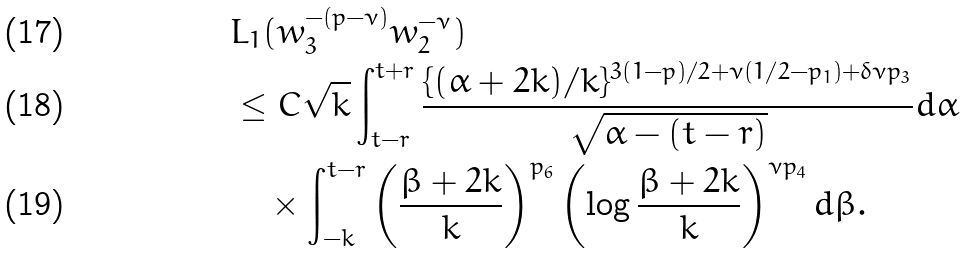<formula> <loc_0><loc_0><loc_500><loc_500>& L _ { 1 } ( w _ { 3 } ^ { - ( p - \nu ) } w _ { 2 } ^ { - \nu } ) \\ & \leq C \sqrt { k } \int _ { t - r } ^ { t + r } \frac { \{ ( \alpha + 2 k ) / k \} ^ { 3 ( 1 - p ) / 2 + \nu ( 1 / 2 - p _ { 1 } ) + \delta \nu p _ { 3 } } } { \sqrt { \alpha - ( t - r ) } } d \alpha \\ & \quad \times \int _ { - k } ^ { t - r } \left ( \frac { \beta + 2 k } { k } \right ) ^ { p _ { 6 } } \left ( \log \frac { \beta + 2 k } { k } \right ) ^ { \nu p _ { 4 } } d \beta .</formula> 